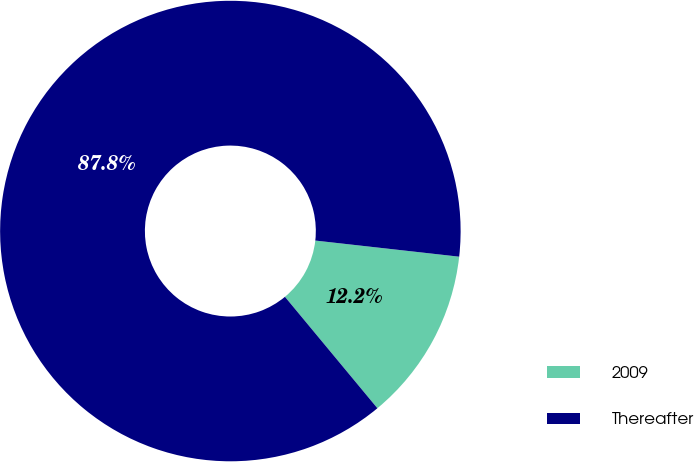Convert chart. <chart><loc_0><loc_0><loc_500><loc_500><pie_chart><fcel>2009<fcel>Thereafter<nl><fcel>12.2%<fcel>87.8%<nl></chart> 